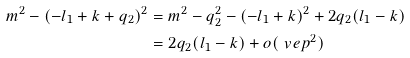<formula> <loc_0><loc_0><loc_500><loc_500>m ^ { 2 } - ( - l _ { 1 } + k + q _ { 2 } ) ^ { 2 } = & \ m ^ { 2 } - q _ { 2 } ^ { 2 } - ( - l _ { 1 } + k ) ^ { 2 } + 2 q _ { 2 } ( l _ { 1 } - k ) \\ = & \ 2 q _ { 2 } ( l _ { 1 } - k ) + o ( \ v e p ^ { 2 } ) \\</formula> 